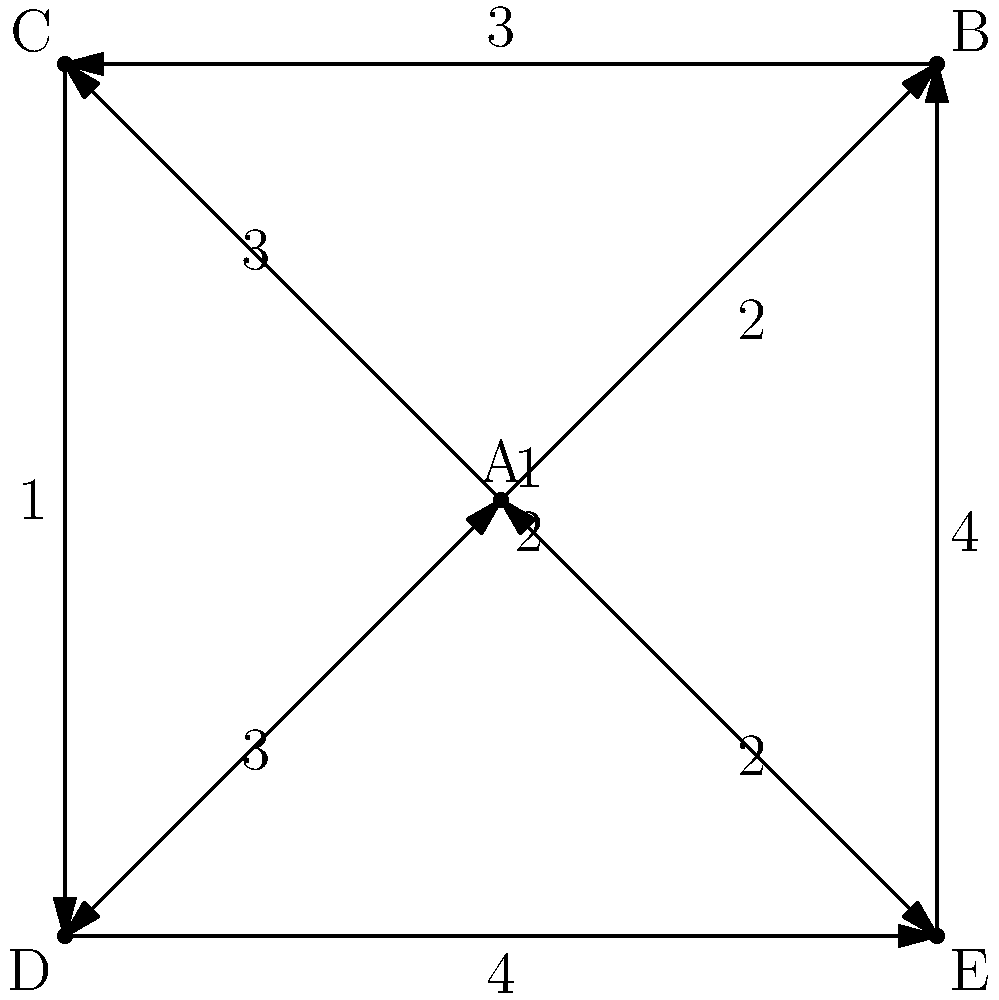In the given graph, chords are represented as nodes (A, B, C, D, E), and the edges represent possible transitions between chords. The weight of each edge indicates the emotional impact of the transition (higher numbers mean stronger impact). What is the maximum emotional impact that can be achieved in a chord progression that starts and ends with chord A, visits each chord exactly once, and follows a valid path in the graph? To solve this problem, we need to find the Hamiltonian cycle with the maximum total weight. Here's a step-by-step approach:

1. Identify all possible Hamiltonian cycles starting and ending with A:
   - A → B → C → D → E → A
   - A → B → D → E → C → A
   - A → C → B → D → E → A
   - A → C → E → D → B → A
   - A → E → B → C → D → A
   - A → E → D → B → C → A

2. Calculate the total weight for each cycle:
   - A → B → C → D → E → A: 2 + 3 + 1 + 4 + 2 = 12
   - A → B → D → E → C → A: 2 + 2 + 4 + 1 + 3 = 12
   - A → C → B → D → E → A: 3 + 3 + 2 + 4 + 2 = 14
   - A → C → E → D → B → A: 3 + 1 + 4 + 2 + 4 = 14
   - A → E → B → C → D → A: 2 + 4 + 3 + 1 + 3 = 13
   - A → E → D → B → C → A: 2 + 4 + 2 + 3 + 3 = 14

3. Identify the maximum total weight:
   The maximum total weight is 14, which can be achieved through three different paths:
   - A → C → B → D → E → A
   - A → C → E → D → B → A
   - A → E → D → B → C → A

Therefore, the maximum emotional impact that can be achieved in a chord progression that starts and ends with chord A, visits each chord exactly once, and follows a valid path in the graph is 14.
Answer: 14 